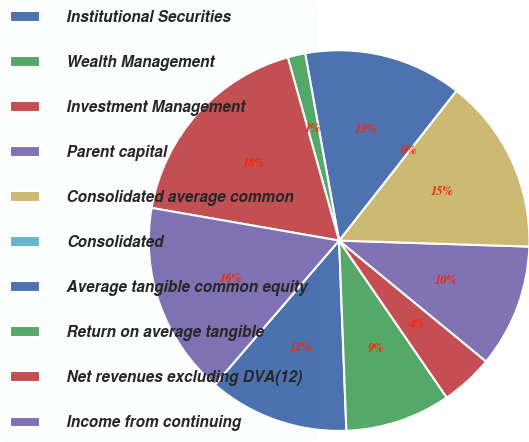Convert chart to OTSL. <chart><loc_0><loc_0><loc_500><loc_500><pie_chart><fcel>Institutional Securities<fcel>Wealth Management<fcel>Investment Management<fcel>Parent capital<fcel>Consolidated average common<fcel>Consolidated<fcel>Average tangible common equity<fcel>Return on average tangible<fcel>Net revenues excluding DVA(12)<fcel>Income from continuing<nl><fcel>11.94%<fcel>8.96%<fcel>4.48%<fcel>10.45%<fcel>14.93%<fcel>0.0%<fcel>13.43%<fcel>1.49%<fcel>17.91%<fcel>16.42%<nl></chart> 